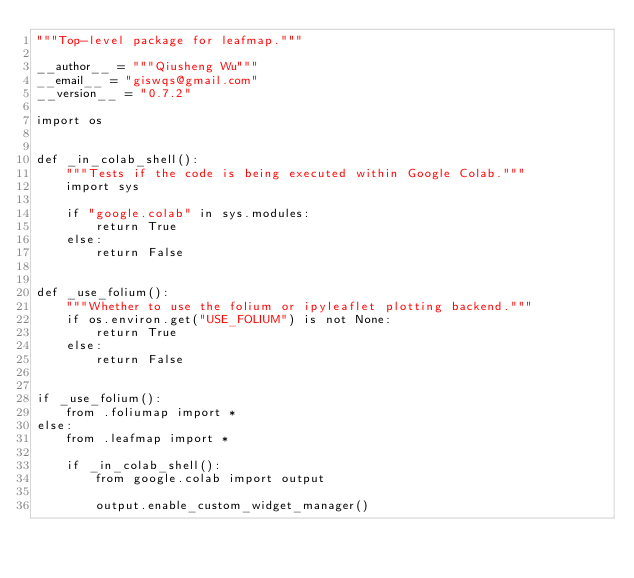Convert code to text. <code><loc_0><loc_0><loc_500><loc_500><_Python_>"""Top-level package for leafmap."""

__author__ = """Qiusheng Wu"""
__email__ = "giswqs@gmail.com"
__version__ = "0.7.2"

import os


def _in_colab_shell():
    """Tests if the code is being executed within Google Colab."""
    import sys

    if "google.colab" in sys.modules:
        return True
    else:
        return False


def _use_folium():
    """Whether to use the folium or ipyleaflet plotting backend."""
    if os.environ.get("USE_FOLIUM") is not None:
        return True
    else:
        return False


if _use_folium():
    from .foliumap import *
else:
    from .leafmap import *

    if _in_colab_shell():
        from google.colab import output

        output.enable_custom_widget_manager()
</code> 